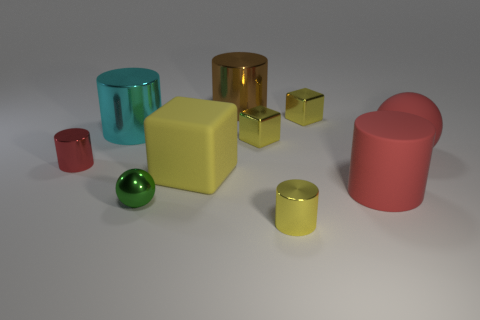How many yellow cubes must be subtracted to get 1 yellow cubes? 2 Subtract all large yellow blocks. How many blocks are left? 2 Subtract all brown cylinders. How many cylinders are left? 4 Subtract 1 red balls. How many objects are left? 9 Subtract all spheres. How many objects are left? 8 Subtract 4 cylinders. How many cylinders are left? 1 Subtract all purple spheres. Subtract all green cylinders. How many spheres are left? 2 Subtract all green blocks. How many red spheres are left? 1 Subtract all big yellow blocks. Subtract all small yellow shiny cylinders. How many objects are left? 8 Add 6 cubes. How many cubes are left? 9 